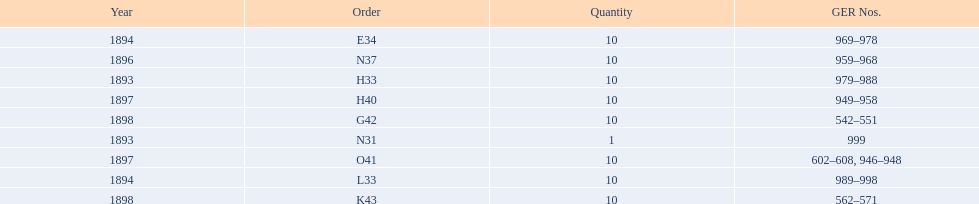What is the total number of locomotives made during this time? 81. Would you be able to parse every entry in this table? {'header': ['Year', 'Order', 'Quantity', 'GER Nos.'], 'rows': [['1894', 'E34', '10', '969–978'], ['1896', 'N37', '10', '959–968'], ['1893', 'H33', '10', '979–988'], ['1897', 'H40', '10', '949–958'], ['1898', 'G42', '10', '542–551'], ['1893', 'N31', '1', '999'], ['1897', 'O41', '10', '602–608, 946–948'], ['1894', 'L33', '10', '989–998'], ['1898', 'K43', '10', '562–571']]} 